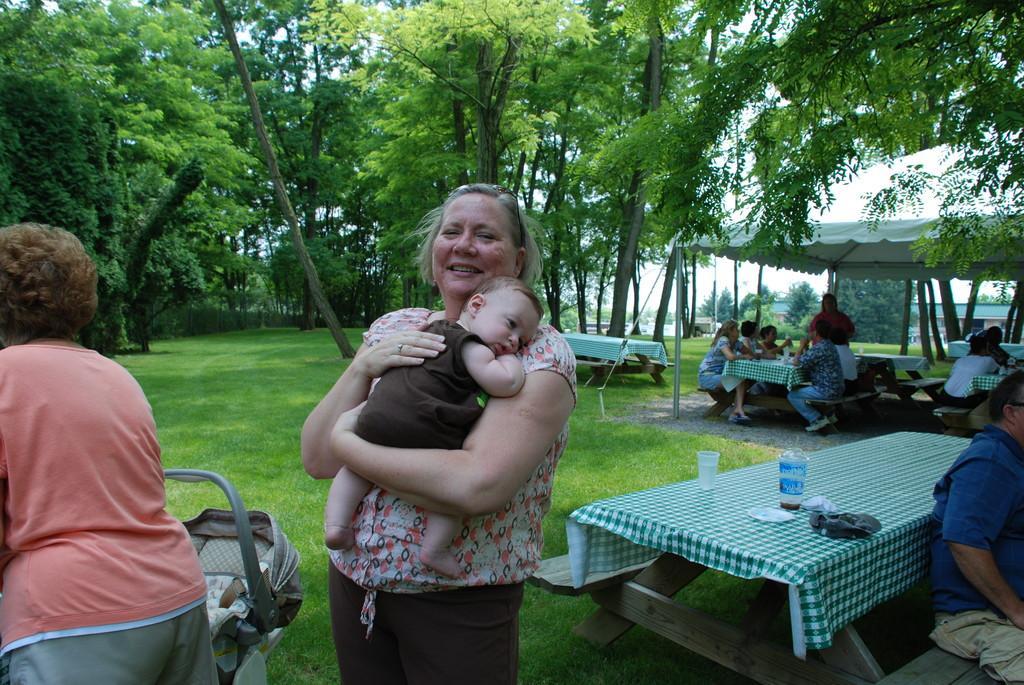Could you give a brief overview of what you see in this image? In the image we can see there is a woman who is holding baby in her hand and at the back there are lot of trees and over there people are sitting on chair. 